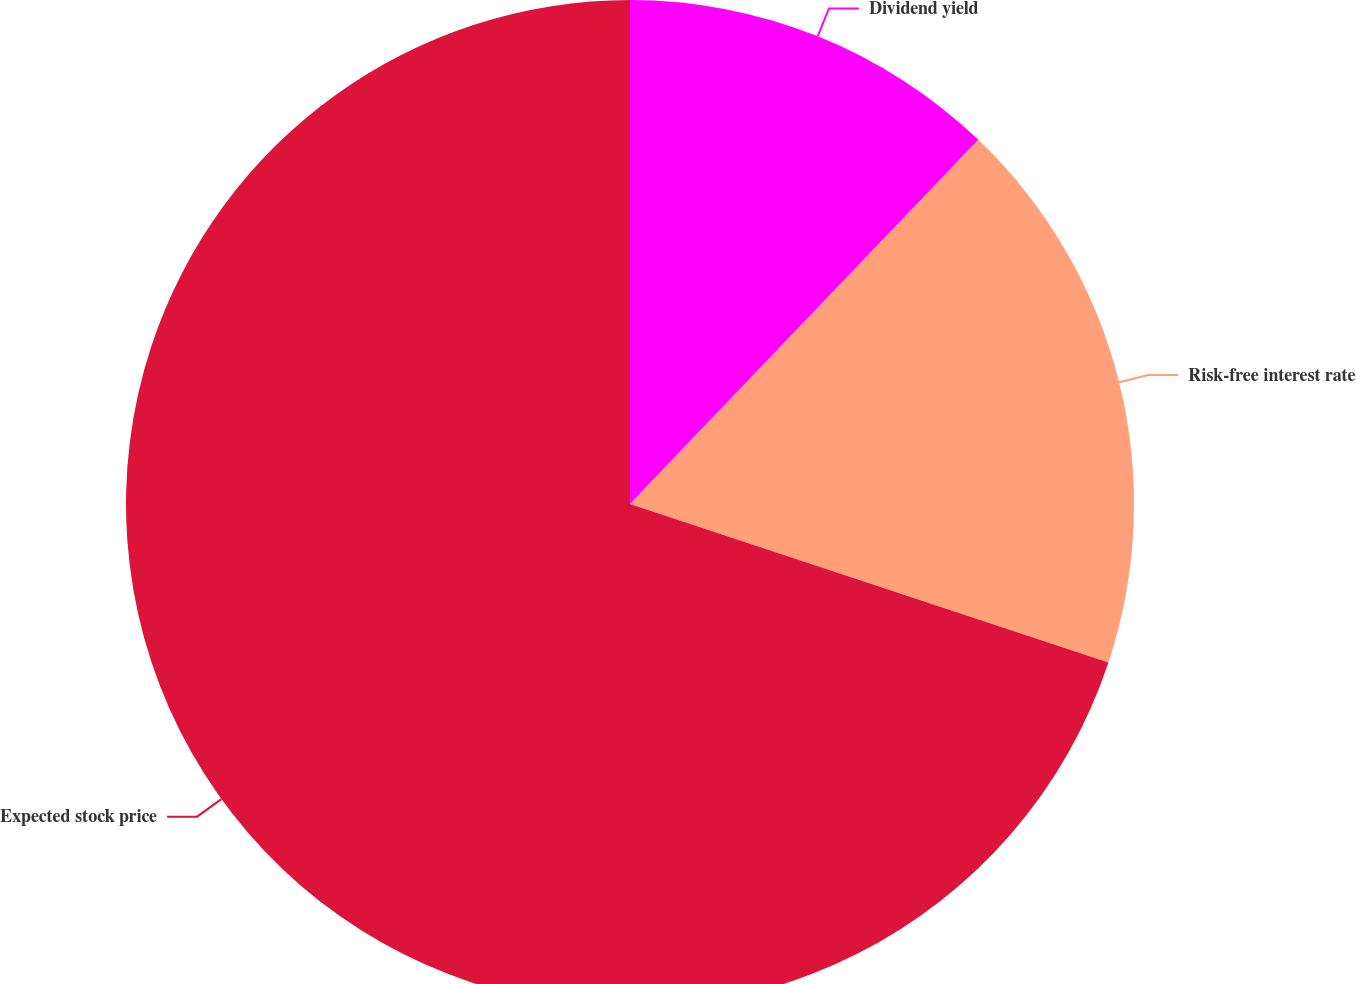<chart> <loc_0><loc_0><loc_500><loc_500><pie_chart><fcel>Dividend yield<fcel>Risk-free interest rate<fcel>Expected stock price<nl><fcel>12.15%<fcel>17.94%<fcel>69.91%<nl></chart> 